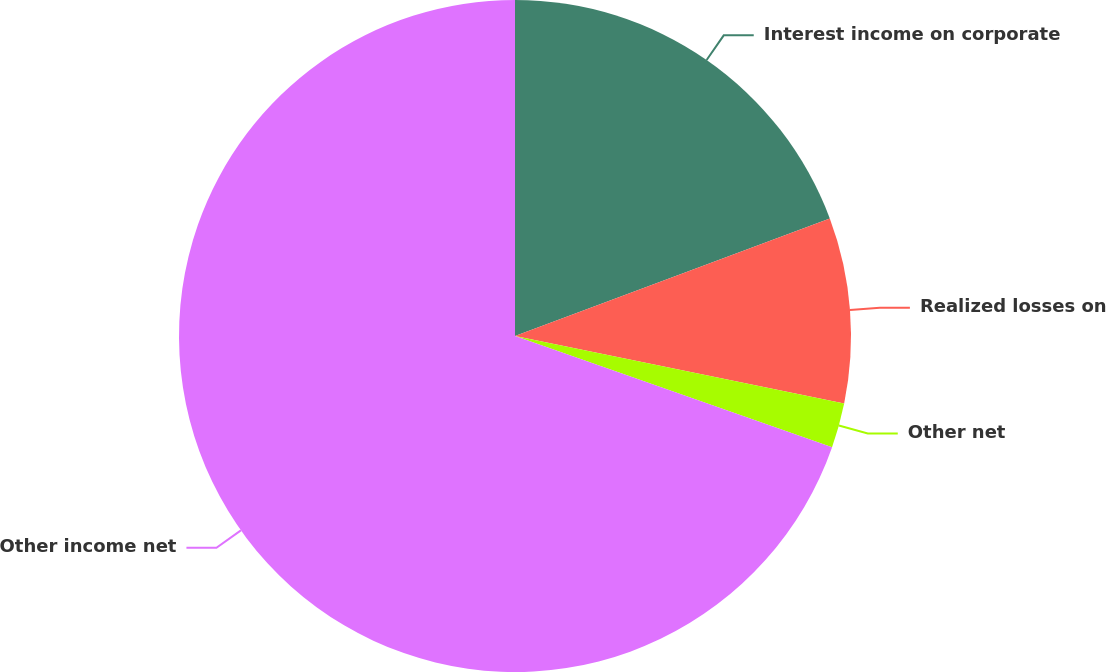<chart> <loc_0><loc_0><loc_500><loc_500><pie_chart><fcel>Interest income on corporate<fcel>Realized losses on<fcel>Other net<fcel>Other income net<nl><fcel>19.32%<fcel>8.9%<fcel>2.15%<fcel>69.64%<nl></chart> 